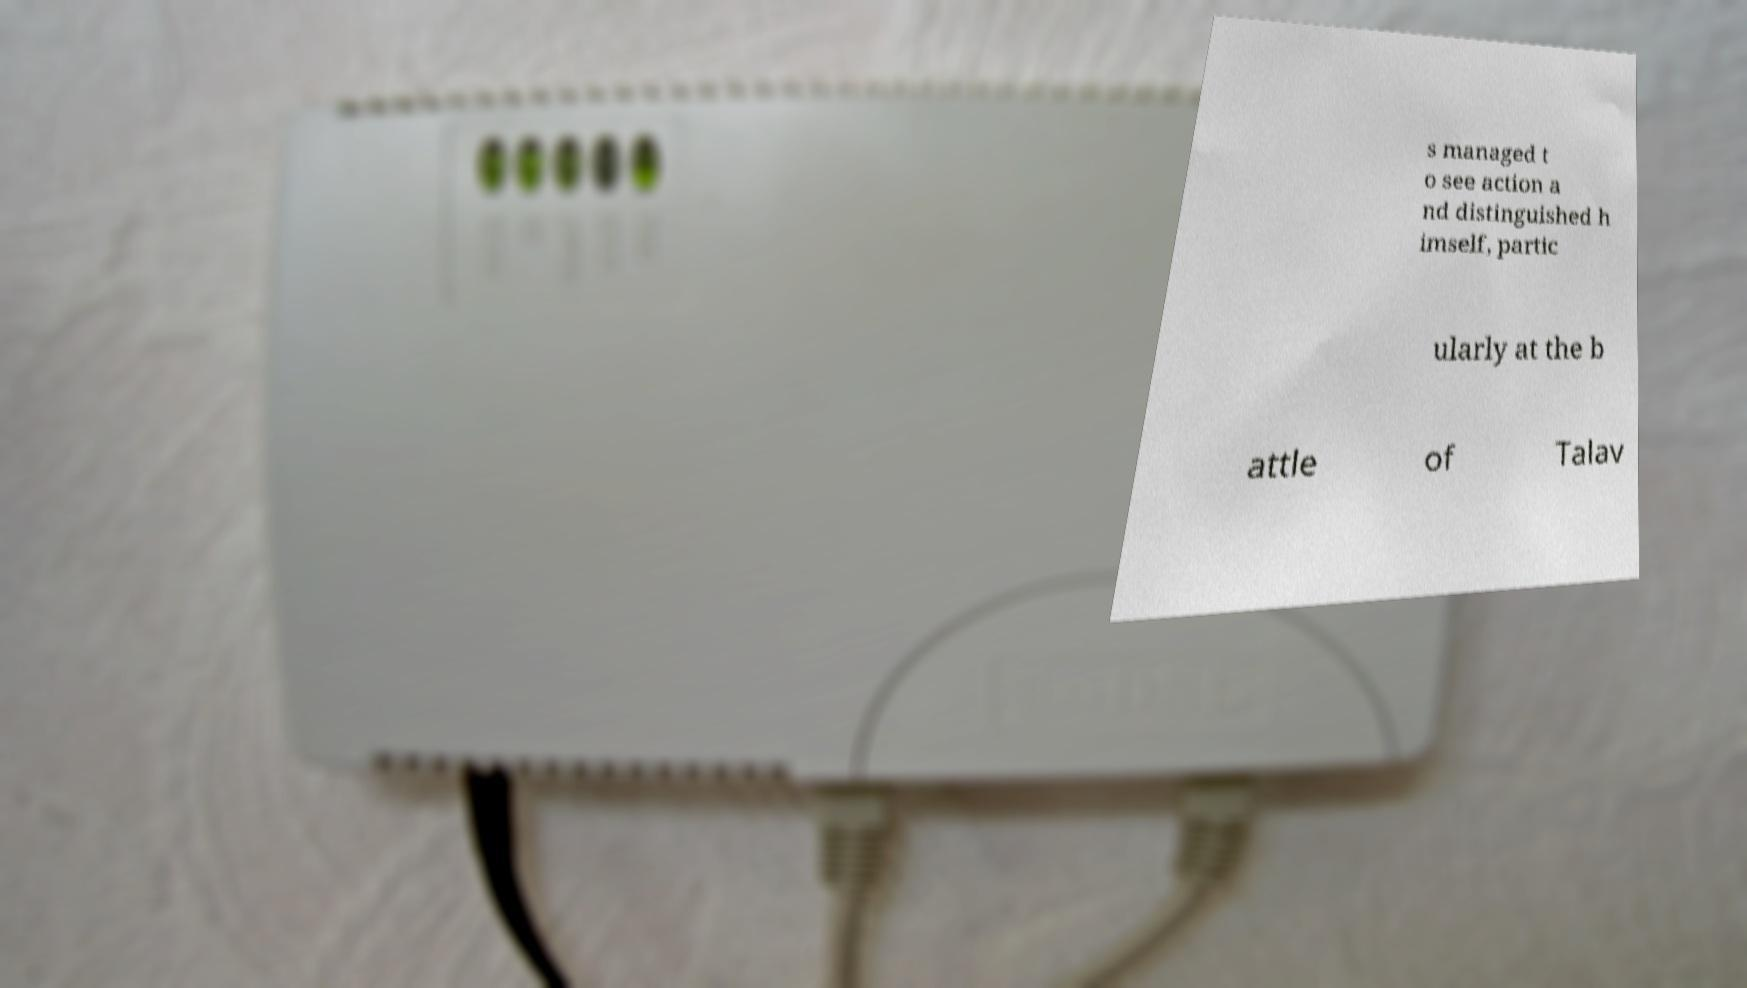Can you accurately transcribe the text from the provided image for me? s managed t o see action a nd distinguished h imself, partic ularly at the b attle of Talav 